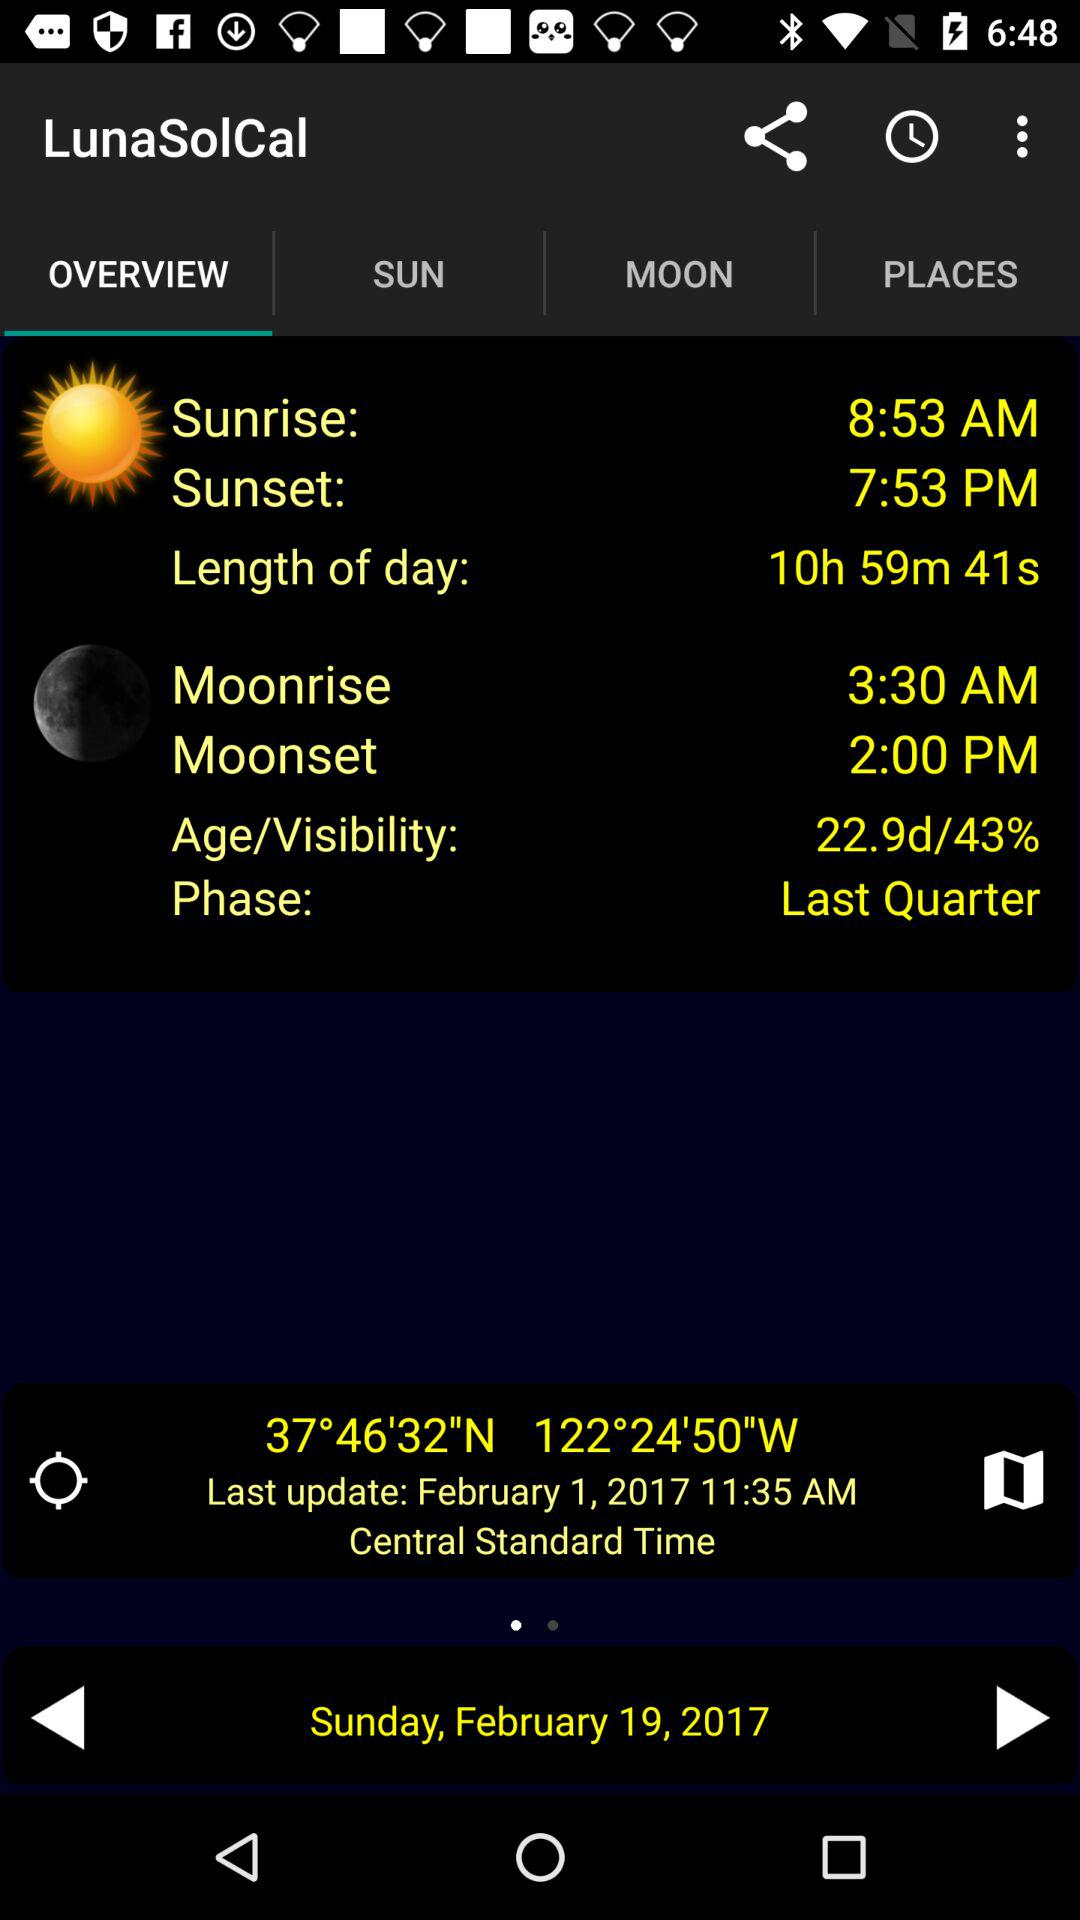What is the on-going phase? The phase is "Last Quarter". 